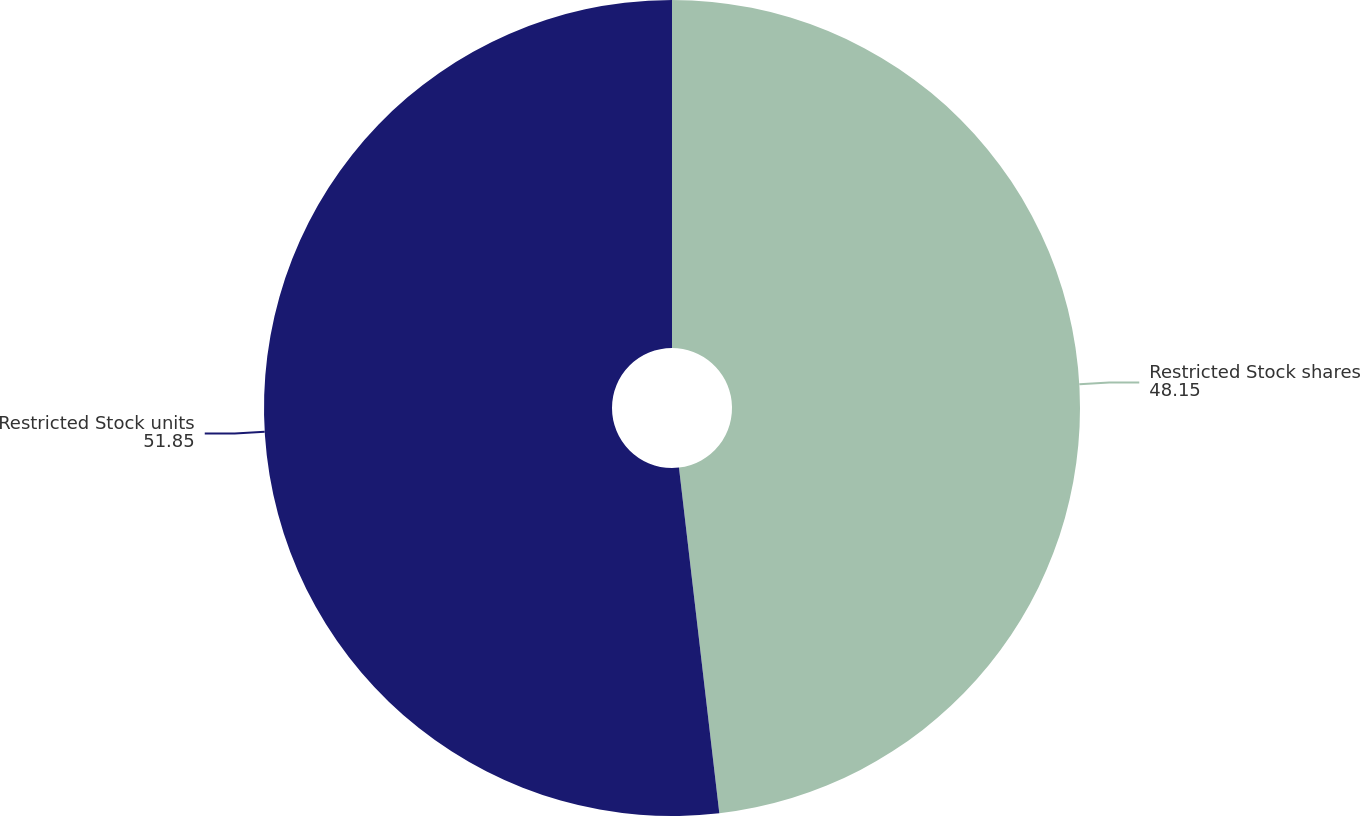<chart> <loc_0><loc_0><loc_500><loc_500><pie_chart><fcel>Restricted Stock shares<fcel>Restricted Stock units<nl><fcel>48.15%<fcel>51.85%<nl></chart> 